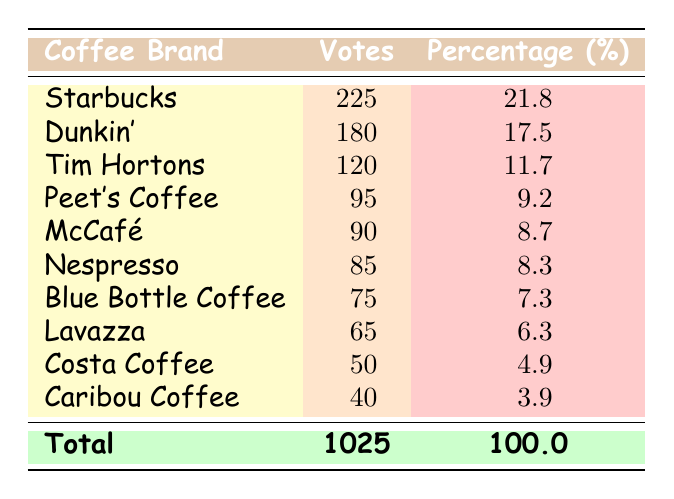What's the most popular coffee brand based on the votes? According to the table, the brand with the highest number of votes is Starbucks, which received 225 votes.
Answer: Starbucks How many votes did Dunkin' receive? The table lists the votes for Dunkin' as 180.
Answer: 180 Is Costa Coffee the least popular brand based on the votes? Looking at the votes, Costa Coffee received 50 votes, which is indeed the lowest among all the brands listed.
Answer: Yes What is the total number of votes received by all coffee brands? The table shows that the total votes from all brands are 1025.
Answer: 1025 Which brand received more votes, Peet's Coffee or Nespresso? Peet's Coffee has 95 votes, while Nespresso has 85 votes. Since 95 is greater than 85, Peet's Coffee received more votes.
Answer: Peet's Coffee What is the percentage of votes for Tim Hortons? The table indicates that Tim Hortons received 120 votes. To find the percentage, calculate (120/1025)*100, which equals approximately 11.7%.
Answer: 11.7% If we combine the votes of Blue Bottle Coffee and Lavazza, how many votes do they have in total? Blue Bottle Coffee has 75 votes, and Lavazza has 65 votes. Adding them together gives 75 + 65 = 140.
Answer: 140 Which coffee brand is in the third place in terms of popularity based on votes? The table ranks the brands, and Tim Hortons, with 120 votes, is in third place after Starbucks and Dunkin'.
Answer: Tim Hortons How many brands received more than 100 votes? From the table, we see that 4 brands received more than 100 votes: Starbucks (225), Dunkin' (180), Tim Hortons (120), and Peet's Coffee (95). Only 3 brands have more than 100 votes, so the calculation is straightforward.
Answer: 3 